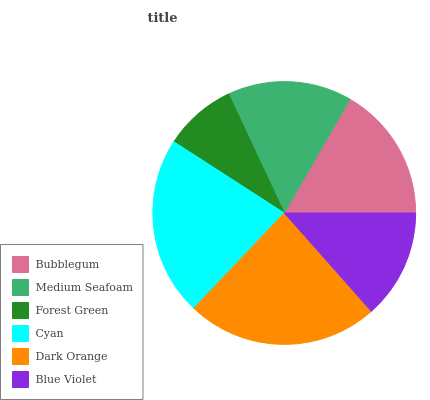Is Forest Green the minimum?
Answer yes or no. Yes. Is Dark Orange the maximum?
Answer yes or no. Yes. Is Medium Seafoam the minimum?
Answer yes or no. No. Is Medium Seafoam the maximum?
Answer yes or no. No. Is Bubblegum greater than Medium Seafoam?
Answer yes or no. Yes. Is Medium Seafoam less than Bubblegum?
Answer yes or no. Yes. Is Medium Seafoam greater than Bubblegum?
Answer yes or no. No. Is Bubblegum less than Medium Seafoam?
Answer yes or no. No. Is Bubblegum the high median?
Answer yes or no. Yes. Is Medium Seafoam the low median?
Answer yes or no. Yes. Is Dark Orange the high median?
Answer yes or no. No. Is Bubblegum the low median?
Answer yes or no. No. 